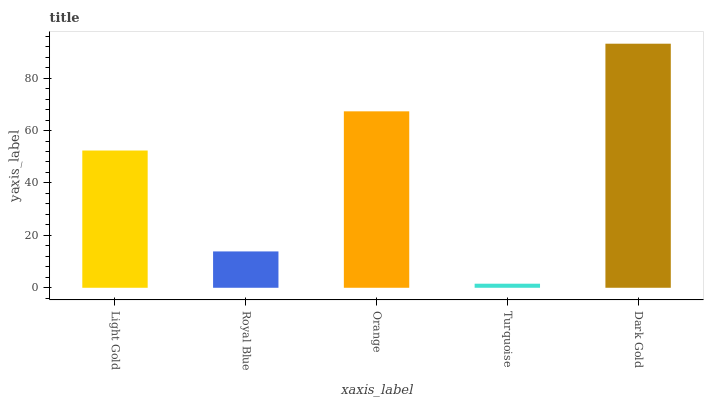Is Turquoise the minimum?
Answer yes or no. Yes. Is Dark Gold the maximum?
Answer yes or no. Yes. Is Royal Blue the minimum?
Answer yes or no. No. Is Royal Blue the maximum?
Answer yes or no. No. Is Light Gold greater than Royal Blue?
Answer yes or no. Yes. Is Royal Blue less than Light Gold?
Answer yes or no. Yes. Is Royal Blue greater than Light Gold?
Answer yes or no. No. Is Light Gold less than Royal Blue?
Answer yes or no. No. Is Light Gold the high median?
Answer yes or no. Yes. Is Light Gold the low median?
Answer yes or no. Yes. Is Royal Blue the high median?
Answer yes or no. No. Is Orange the low median?
Answer yes or no. No. 